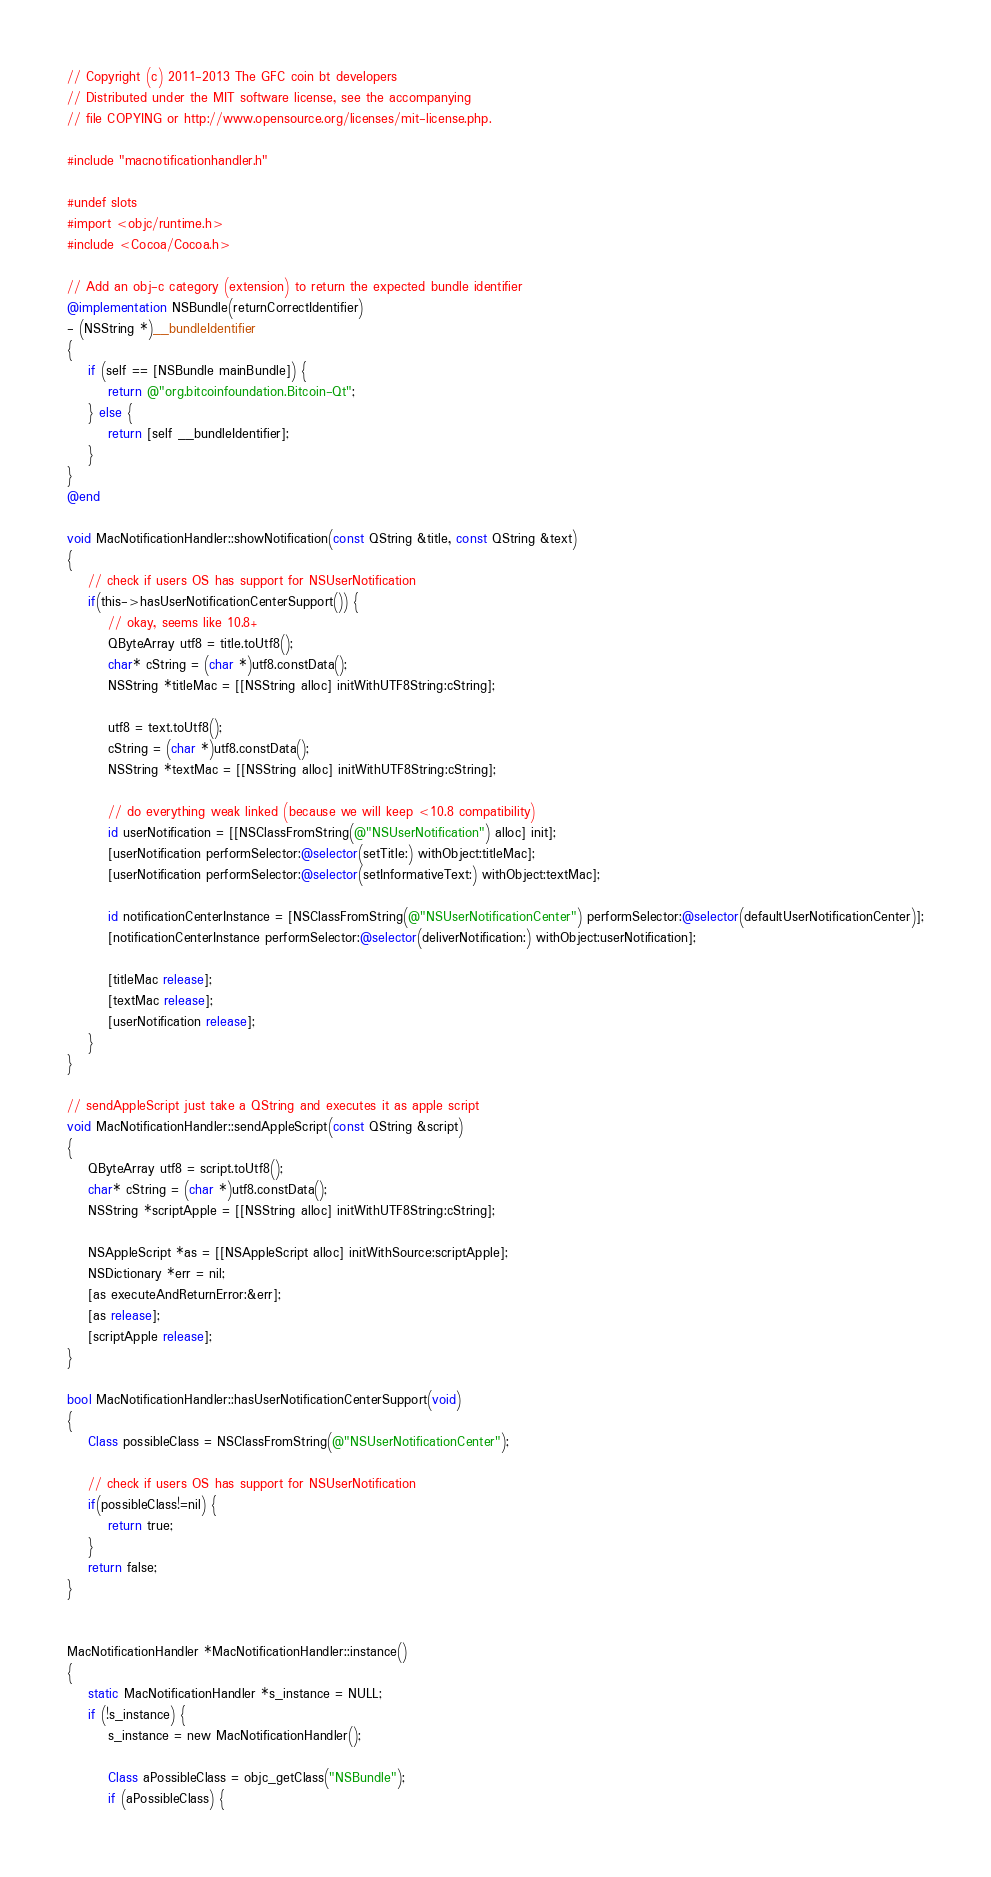Convert code to text. <code><loc_0><loc_0><loc_500><loc_500><_ObjectiveC_>// Copyright (c) 2011-2013 The GFC coin bt developers
// Distributed under the MIT software license, see the accompanying
// file COPYING or http://www.opensource.org/licenses/mit-license.php.

#include "macnotificationhandler.h"

#undef slots
#import <objc/runtime.h>
#include <Cocoa/Cocoa.h>

// Add an obj-c category (extension) to return the expected bundle identifier
@implementation NSBundle(returnCorrectIdentifier)
- (NSString *)__bundleIdentifier
{
    if (self == [NSBundle mainBundle]) {
        return @"org.bitcoinfoundation.Bitcoin-Qt";
    } else {
        return [self __bundleIdentifier];
    }
}
@end

void MacNotificationHandler::showNotification(const QString &title, const QString &text)
{
    // check if users OS has support for NSUserNotification
    if(this->hasUserNotificationCenterSupport()) {
        // okay, seems like 10.8+
        QByteArray utf8 = title.toUtf8();
        char* cString = (char *)utf8.constData();
        NSString *titleMac = [[NSString alloc] initWithUTF8String:cString];

        utf8 = text.toUtf8();
        cString = (char *)utf8.constData();
        NSString *textMac = [[NSString alloc] initWithUTF8String:cString];

        // do everything weak linked (because we will keep <10.8 compatibility)
        id userNotification = [[NSClassFromString(@"NSUserNotification") alloc] init];
        [userNotification performSelector:@selector(setTitle:) withObject:titleMac];
        [userNotification performSelector:@selector(setInformativeText:) withObject:textMac];

        id notificationCenterInstance = [NSClassFromString(@"NSUserNotificationCenter") performSelector:@selector(defaultUserNotificationCenter)];
        [notificationCenterInstance performSelector:@selector(deliverNotification:) withObject:userNotification];

        [titleMac release];
        [textMac release];
        [userNotification release];
    }
}

// sendAppleScript just take a QString and executes it as apple script
void MacNotificationHandler::sendAppleScript(const QString &script)
{
    QByteArray utf8 = script.toUtf8();
    char* cString = (char *)utf8.constData();
    NSString *scriptApple = [[NSString alloc] initWithUTF8String:cString];

    NSAppleScript *as = [[NSAppleScript alloc] initWithSource:scriptApple];
    NSDictionary *err = nil;
    [as executeAndReturnError:&err];
    [as release];
    [scriptApple release];
}

bool MacNotificationHandler::hasUserNotificationCenterSupport(void)
{
    Class possibleClass = NSClassFromString(@"NSUserNotificationCenter");

    // check if users OS has support for NSUserNotification
    if(possibleClass!=nil) {
        return true;
    }
    return false;
}


MacNotificationHandler *MacNotificationHandler::instance()
{
    static MacNotificationHandler *s_instance = NULL;
    if (!s_instance) {
        s_instance = new MacNotificationHandler();
        
        Class aPossibleClass = objc_getClass("NSBundle");
        if (aPossibleClass) {</code> 